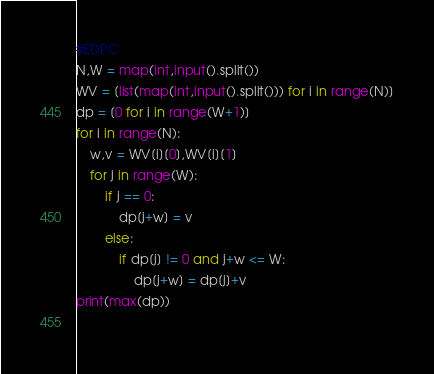Convert code to text. <code><loc_0><loc_0><loc_500><loc_500><_Python_>#EDPC
N,W = map(int,input().split())
WV = [list(map(int,input().split())) for i in range(N)]
dp = [0 for i in range(W+1)]
for i in range(N):
    w,v = WV[i][0],WV[i][1]
    for j in range(W):
        if j == 0:
            dp[j+w] = v
        else:
            if dp[j] != 0 and j+w <= W:
                dp[j+w] = dp[j]+v
print(max(dp))
    </code> 